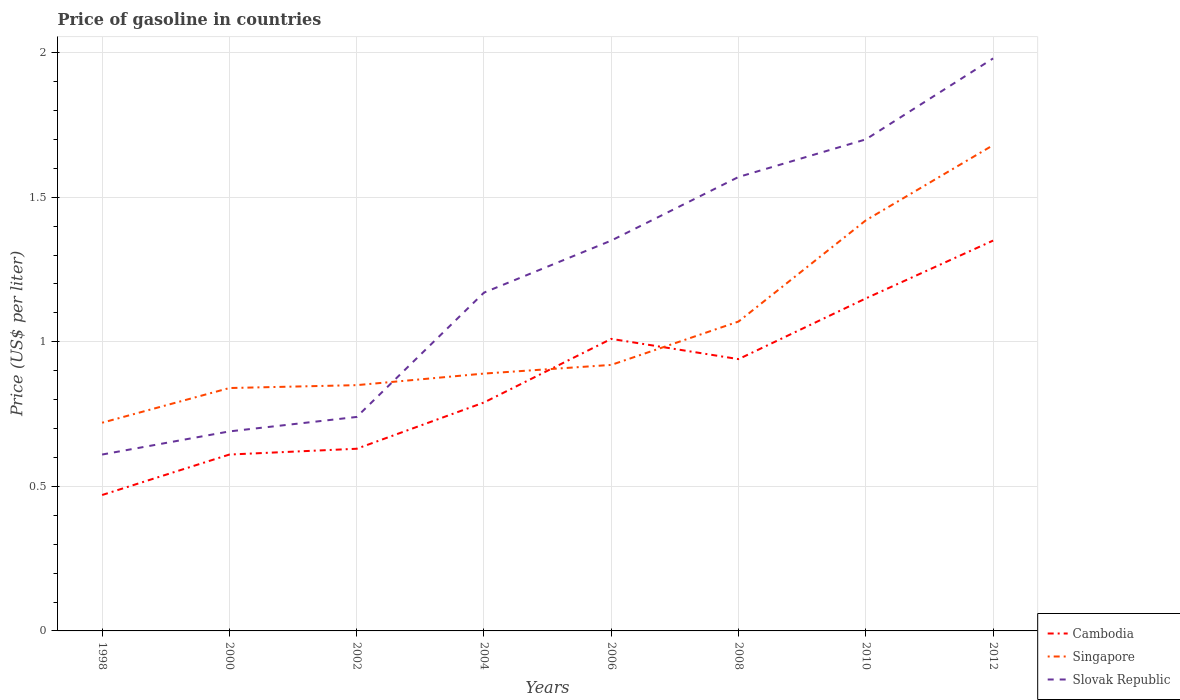How many different coloured lines are there?
Your answer should be compact. 3. Does the line corresponding to Slovak Republic intersect with the line corresponding to Cambodia?
Give a very brief answer. No. Across all years, what is the maximum price of gasoline in Cambodia?
Provide a succinct answer. 0.47. What is the total price of gasoline in Singapore in the graph?
Provide a short and direct response. -0.5. What is the difference between the highest and the second highest price of gasoline in Slovak Republic?
Make the answer very short. 1.37. What is the difference between the highest and the lowest price of gasoline in Singapore?
Offer a terse response. 3. Is the price of gasoline in Cambodia strictly greater than the price of gasoline in Singapore over the years?
Keep it short and to the point. No. How many lines are there?
Your response must be concise. 3. Are the values on the major ticks of Y-axis written in scientific E-notation?
Provide a short and direct response. No. Does the graph contain any zero values?
Give a very brief answer. No. Where does the legend appear in the graph?
Make the answer very short. Bottom right. What is the title of the graph?
Your response must be concise. Price of gasoline in countries. Does "Mongolia" appear as one of the legend labels in the graph?
Your answer should be compact. No. What is the label or title of the X-axis?
Provide a short and direct response. Years. What is the label or title of the Y-axis?
Offer a terse response. Price (US$ per liter). What is the Price (US$ per liter) in Cambodia in 1998?
Give a very brief answer. 0.47. What is the Price (US$ per liter) of Singapore in 1998?
Make the answer very short. 0.72. What is the Price (US$ per liter) of Slovak Republic in 1998?
Ensure brevity in your answer.  0.61. What is the Price (US$ per liter) of Cambodia in 2000?
Provide a short and direct response. 0.61. What is the Price (US$ per liter) in Singapore in 2000?
Give a very brief answer. 0.84. What is the Price (US$ per liter) of Slovak Republic in 2000?
Your response must be concise. 0.69. What is the Price (US$ per liter) in Cambodia in 2002?
Offer a very short reply. 0.63. What is the Price (US$ per liter) in Singapore in 2002?
Keep it short and to the point. 0.85. What is the Price (US$ per liter) of Slovak Republic in 2002?
Provide a short and direct response. 0.74. What is the Price (US$ per liter) in Cambodia in 2004?
Your response must be concise. 0.79. What is the Price (US$ per liter) in Singapore in 2004?
Provide a succinct answer. 0.89. What is the Price (US$ per liter) in Slovak Republic in 2004?
Provide a succinct answer. 1.17. What is the Price (US$ per liter) of Singapore in 2006?
Your answer should be compact. 0.92. What is the Price (US$ per liter) in Slovak Republic in 2006?
Make the answer very short. 1.35. What is the Price (US$ per liter) in Singapore in 2008?
Keep it short and to the point. 1.07. What is the Price (US$ per liter) in Slovak Republic in 2008?
Your answer should be very brief. 1.57. What is the Price (US$ per liter) of Cambodia in 2010?
Provide a short and direct response. 1.15. What is the Price (US$ per liter) of Singapore in 2010?
Offer a terse response. 1.42. What is the Price (US$ per liter) of Slovak Republic in 2010?
Make the answer very short. 1.7. What is the Price (US$ per liter) in Cambodia in 2012?
Make the answer very short. 1.35. What is the Price (US$ per liter) in Singapore in 2012?
Your answer should be compact. 1.68. What is the Price (US$ per liter) in Slovak Republic in 2012?
Your answer should be very brief. 1.98. Across all years, what is the maximum Price (US$ per liter) in Cambodia?
Provide a succinct answer. 1.35. Across all years, what is the maximum Price (US$ per liter) in Singapore?
Offer a terse response. 1.68. Across all years, what is the maximum Price (US$ per liter) of Slovak Republic?
Provide a succinct answer. 1.98. Across all years, what is the minimum Price (US$ per liter) in Cambodia?
Give a very brief answer. 0.47. Across all years, what is the minimum Price (US$ per liter) of Singapore?
Your response must be concise. 0.72. Across all years, what is the minimum Price (US$ per liter) in Slovak Republic?
Give a very brief answer. 0.61. What is the total Price (US$ per liter) in Cambodia in the graph?
Make the answer very short. 6.95. What is the total Price (US$ per liter) in Singapore in the graph?
Offer a terse response. 8.39. What is the total Price (US$ per liter) in Slovak Republic in the graph?
Offer a very short reply. 9.81. What is the difference between the Price (US$ per liter) in Cambodia in 1998 and that in 2000?
Offer a very short reply. -0.14. What is the difference between the Price (US$ per liter) of Singapore in 1998 and that in 2000?
Keep it short and to the point. -0.12. What is the difference between the Price (US$ per liter) of Slovak Republic in 1998 and that in 2000?
Offer a terse response. -0.08. What is the difference between the Price (US$ per liter) of Cambodia in 1998 and that in 2002?
Keep it short and to the point. -0.16. What is the difference between the Price (US$ per liter) in Singapore in 1998 and that in 2002?
Provide a succinct answer. -0.13. What is the difference between the Price (US$ per liter) in Slovak Republic in 1998 and that in 2002?
Your response must be concise. -0.13. What is the difference between the Price (US$ per liter) of Cambodia in 1998 and that in 2004?
Your answer should be very brief. -0.32. What is the difference between the Price (US$ per liter) in Singapore in 1998 and that in 2004?
Provide a succinct answer. -0.17. What is the difference between the Price (US$ per liter) in Slovak Republic in 1998 and that in 2004?
Offer a terse response. -0.56. What is the difference between the Price (US$ per liter) in Cambodia in 1998 and that in 2006?
Provide a short and direct response. -0.54. What is the difference between the Price (US$ per liter) of Slovak Republic in 1998 and that in 2006?
Offer a very short reply. -0.74. What is the difference between the Price (US$ per liter) of Cambodia in 1998 and that in 2008?
Give a very brief answer. -0.47. What is the difference between the Price (US$ per liter) of Singapore in 1998 and that in 2008?
Provide a succinct answer. -0.35. What is the difference between the Price (US$ per liter) of Slovak Republic in 1998 and that in 2008?
Offer a very short reply. -0.96. What is the difference between the Price (US$ per liter) of Cambodia in 1998 and that in 2010?
Offer a very short reply. -0.68. What is the difference between the Price (US$ per liter) in Slovak Republic in 1998 and that in 2010?
Give a very brief answer. -1.09. What is the difference between the Price (US$ per liter) of Cambodia in 1998 and that in 2012?
Your answer should be very brief. -0.88. What is the difference between the Price (US$ per liter) in Singapore in 1998 and that in 2012?
Your answer should be compact. -0.96. What is the difference between the Price (US$ per liter) of Slovak Republic in 1998 and that in 2012?
Keep it short and to the point. -1.37. What is the difference between the Price (US$ per liter) in Cambodia in 2000 and that in 2002?
Your answer should be compact. -0.02. What is the difference between the Price (US$ per liter) of Singapore in 2000 and that in 2002?
Ensure brevity in your answer.  -0.01. What is the difference between the Price (US$ per liter) in Cambodia in 2000 and that in 2004?
Provide a succinct answer. -0.18. What is the difference between the Price (US$ per liter) of Singapore in 2000 and that in 2004?
Ensure brevity in your answer.  -0.05. What is the difference between the Price (US$ per liter) of Slovak Republic in 2000 and that in 2004?
Offer a very short reply. -0.48. What is the difference between the Price (US$ per liter) in Cambodia in 2000 and that in 2006?
Offer a very short reply. -0.4. What is the difference between the Price (US$ per liter) in Singapore in 2000 and that in 2006?
Keep it short and to the point. -0.08. What is the difference between the Price (US$ per liter) of Slovak Republic in 2000 and that in 2006?
Offer a very short reply. -0.66. What is the difference between the Price (US$ per liter) in Cambodia in 2000 and that in 2008?
Ensure brevity in your answer.  -0.33. What is the difference between the Price (US$ per liter) of Singapore in 2000 and that in 2008?
Your answer should be very brief. -0.23. What is the difference between the Price (US$ per liter) in Slovak Republic in 2000 and that in 2008?
Offer a very short reply. -0.88. What is the difference between the Price (US$ per liter) of Cambodia in 2000 and that in 2010?
Give a very brief answer. -0.54. What is the difference between the Price (US$ per liter) of Singapore in 2000 and that in 2010?
Provide a succinct answer. -0.58. What is the difference between the Price (US$ per liter) in Slovak Republic in 2000 and that in 2010?
Your response must be concise. -1.01. What is the difference between the Price (US$ per liter) in Cambodia in 2000 and that in 2012?
Make the answer very short. -0.74. What is the difference between the Price (US$ per liter) in Singapore in 2000 and that in 2012?
Make the answer very short. -0.84. What is the difference between the Price (US$ per liter) of Slovak Republic in 2000 and that in 2012?
Offer a very short reply. -1.29. What is the difference between the Price (US$ per liter) of Cambodia in 2002 and that in 2004?
Offer a very short reply. -0.16. What is the difference between the Price (US$ per liter) of Singapore in 2002 and that in 2004?
Keep it short and to the point. -0.04. What is the difference between the Price (US$ per liter) of Slovak Republic in 2002 and that in 2004?
Give a very brief answer. -0.43. What is the difference between the Price (US$ per liter) of Cambodia in 2002 and that in 2006?
Provide a succinct answer. -0.38. What is the difference between the Price (US$ per liter) of Singapore in 2002 and that in 2006?
Ensure brevity in your answer.  -0.07. What is the difference between the Price (US$ per liter) of Slovak Republic in 2002 and that in 2006?
Your response must be concise. -0.61. What is the difference between the Price (US$ per liter) in Cambodia in 2002 and that in 2008?
Make the answer very short. -0.31. What is the difference between the Price (US$ per liter) in Singapore in 2002 and that in 2008?
Make the answer very short. -0.22. What is the difference between the Price (US$ per liter) in Slovak Republic in 2002 and that in 2008?
Offer a very short reply. -0.83. What is the difference between the Price (US$ per liter) of Cambodia in 2002 and that in 2010?
Give a very brief answer. -0.52. What is the difference between the Price (US$ per liter) in Singapore in 2002 and that in 2010?
Keep it short and to the point. -0.57. What is the difference between the Price (US$ per liter) of Slovak Republic in 2002 and that in 2010?
Ensure brevity in your answer.  -0.96. What is the difference between the Price (US$ per liter) of Cambodia in 2002 and that in 2012?
Your answer should be compact. -0.72. What is the difference between the Price (US$ per liter) of Singapore in 2002 and that in 2012?
Your answer should be compact. -0.83. What is the difference between the Price (US$ per liter) in Slovak Republic in 2002 and that in 2012?
Make the answer very short. -1.24. What is the difference between the Price (US$ per liter) in Cambodia in 2004 and that in 2006?
Give a very brief answer. -0.22. What is the difference between the Price (US$ per liter) in Singapore in 2004 and that in 2006?
Your answer should be compact. -0.03. What is the difference between the Price (US$ per liter) of Slovak Republic in 2004 and that in 2006?
Your answer should be very brief. -0.18. What is the difference between the Price (US$ per liter) of Singapore in 2004 and that in 2008?
Keep it short and to the point. -0.18. What is the difference between the Price (US$ per liter) in Cambodia in 2004 and that in 2010?
Keep it short and to the point. -0.36. What is the difference between the Price (US$ per liter) of Singapore in 2004 and that in 2010?
Give a very brief answer. -0.53. What is the difference between the Price (US$ per liter) of Slovak Republic in 2004 and that in 2010?
Provide a succinct answer. -0.53. What is the difference between the Price (US$ per liter) of Cambodia in 2004 and that in 2012?
Your answer should be compact. -0.56. What is the difference between the Price (US$ per liter) of Singapore in 2004 and that in 2012?
Provide a short and direct response. -0.79. What is the difference between the Price (US$ per liter) of Slovak Republic in 2004 and that in 2012?
Your answer should be very brief. -0.81. What is the difference between the Price (US$ per liter) in Cambodia in 2006 and that in 2008?
Provide a short and direct response. 0.07. What is the difference between the Price (US$ per liter) in Slovak Republic in 2006 and that in 2008?
Give a very brief answer. -0.22. What is the difference between the Price (US$ per liter) of Cambodia in 2006 and that in 2010?
Offer a terse response. -0.14. What is the difference between the Price (US$ per liter) in Singapore in 2006 and that in 2010?
Keep it short and to the point. -0.5. What is the difference between the Price (US$ per liter) of Slovak Republic in 2006 and that in 2010?
Offer a very short reply. -0.35. What is the difference between the Price (US$ per liter) of Cambodia in 2006 and that in 2012?
Offer a terse response. -0.34. What is the difference between the Price (US$ per liter) of Singapore in 2006 and that in 2012?
Offer a very short reply. -0.76. What is the difference between the Price (US$ per liter) in Slovak Republic in 2006 and that in 2012?
Your answer should be compact. -0.63. What is the difference between the Price (US$ per liter) in Cambodia in 2008 and that in 2010?
Make the answer very short. -0.21. What is the difference between the Price (US$ per liter) in Singapore in 2008 and that in 2010?
Your answer should be compact. -0.35. What is the difference between the Price (US$ per liter) of Slovak Republic in 2008 and that in 2010?
Give a very brief answer. -0.13. What is the difference between the Price (US$ per liter) in Cambodia in 2008 and that in 2012?
Your answer should be very brief. -0.41. What is the difference between the Price (US$ per liter) of Singapore in 2008 and that in 2012?
Your answer should be very brief. -0.61. What is the difference between the Price (US$ per liter) in Slovak Republic in 2008 and that in 2012?
Your answer should be compact. -0.41. What is the difference between the Price (US$ per liter) of Singapore in 2010 and that in 2012?
Offer a very short reply. -0.26. What is the difference between the Price (US$ per liter) of Slovak Republic in 2010 and that in 2012?
Your answer should be very brief. -0.28. What is the difference between the Price (US$ per liter) in Cambodia in 1998 and the Price (US$ per liter) in Singapore in 2000?
Keep it short and to the point. -0.37. What is the difference between the Price (US$ per liter) of Cambodia in 1998 and the Price (US$ per liter) of Slovak Republic in 2000?
Your response must be concise. -0.22. What is the difference between the Price (US$ per liter) in Cambodia in 1998 and the Price (US$ per liter) in Singapore in 2002?
Offer a very short reply. -0.38. What is the difference between the Price (US$ per liter) of Cambodia in 1998 and the Price (US$ per liter) of Slovak Republic in 2002?
Provide a short and direct response. -0.27. What is the difference between the Price (US$ per liter) in Singapore in 1998 and the Price (US$ per liter) in Slovak Republic in 2002?
Offer a terse response. -0.02. What is the difference between the Price (US$ per liter) of Cambodia in 1998 and the Price (US$ per liter) of Singapore in 2004?
Your response must be concise. -0.42. What is the difference between the Price (US$ per liter) of Cambodia in 1998 and the Price (US$ per liter) of Slovak Republic in 2004?
Your answer should be compact. -0.7. What is the difference between the Price (US$ per liter) of Singapore in 1998 and the Price (US$ per liter) of Slovak Republic in 2004?
Your response must be concise. -0.45. What is the difference between the Price (US$ per liter) in Cambodia in 1998 and the Price (US$ per liter) in Singapore in 2006?
Your response must be concise. -0.45. What is the difference between the Price (US$ per liter) of Cambodia in 1998 and the Price (US$ per liter) of Slovak Republic in 2006?
Keep it short and to the point. -0.88. What is the difference between the Price (US$ per liter) in Singapore in 1998 and the Price (US$ per liter) in Slovak Republic in 2006?
Give a very brief answer. -0.63. What is the difference between the Price (US$ per liter) of Cambodia in 1998 and the Price (US$ per liter) of Singapore in 2008?
Provide a succinct answer. -0.6. What is the difference between the Price (US$ per liter) in Singapore in 1998 and the Price (US$ per liter) in Slovak Republic in 2008?
Offer a very short reply. -0.85. What is the difference between the Price (US$ per liter) of Cambodia in 1998 and the Price (US$ per liter) of Singapore in 2010?
Ensure brevity in your answer.  -0.95. What is the difference between the Price (US$ per liter) of Cambodia in 1998 and the Price (US$ per liter) of Slovak Republic in 2010?
Offer a terse response. -1.23. What is the difference between the Price (US$ per liter) of Singapore in 1998 and the Price (US$ per liter) of Slovak Republic in 2010?
Make the answer very short. -0.98. What is the difference between the Price (US$ per liter) of Cambodia in 1998 and the Price (US$ per liter) of Singapore in 2012?
Ensure brevity in your answer.  -1.21. What is the difference between the Price (US$ per liter) of Cambodia in 1998 and the Price (US$ per liter) of Slovak Republic in 2012?
Provide a succinct answer. -1.51. What is the difference between the Price (US$ per liter) of Singapore in 1998 and the Price (US$ per liter) of Slovak Republic in 2012?
Give a very brief answer. -1.26. What is the difference between the Price (US$ per liter) of Cambodia in 2000 and the Price (US$ per liter) of Singapore in 2002?
Ensure brevity in your answer.  -0.24. What is the difference between the Price (US$ per liter) of Cambodia in 2000 and the Price (US$ per liter) of Slovak Republic in 2002?
Your response must be concise. -0.13. What is the difference between the Price (US$ per liter) of Singapore in 2000 and the Price (US$ per liter) of Slovak Republic in 2002?
Make the answer very short. 0.1. What is the difference between the Price (US$ per liter) in Cambodia in 2000 and the Price (US$ per liter) in Singapore in 2004?
Your response must be concise. -0.28. What is the difference between the Price (US$ per liter) in Cambodia in 2000 and the Price (US$ per liter) in Slovak Republic in 2004?
Your response must be concise. -0.56. What is the difference between the Price (US$ per liter) in Singapore in 2000 and the Price (US$ per liter) in Slovak Republic in 2004?
Ensure brevity in your answer.  -0.33. What is the difference between the Price (US$ per liter) of Cambodia in 2000 and the Price (US$ per liter) of Singapore in 2006?
Offer a very short reply. -0.31. What is the difference between the Price (US$ per liter) of Cambodia in 2000 and the Price (US$ per liter) of Slovak Republic in 2006?
Provide a succinct answer. -0.74. What is the difference between the Price (US$ per liter) of Singapore in 2000 and the Price (US$ per liter) of Slovak Republic in 2006?
Keep it short and to the point. -0.51. What is the difference between the Price (US$ per liter) of Cambodia in 2000 and the Price (US$ per liter) of Singapore in 2008?
Your answer should be compact. -0.46. What is the difference between the Price (US$ per liter) of Cambodia in 2000 and the Price (US$ per liter) of Slovak Republic in 2008?
Provide a succinct answer. -0.96. What is the difference between the Price (US$ per liter) in Singapore in 2000 and the Price (US$ per liter) in Slovak Republic in 2008?
Your response must be concise. -0.73. What is the difference between the Price (US$ per liter) in Cambodia in 2000 and the Price (US$ per liter) in Singapore in 2010?
Offer a terse response. -0.81. What is the difference between the Price (US$ per liter) of Cambodia in 2000 and the Price (US$ per liter) of Slovak Republic in 2010?
Your answer should be very brief. -1.09. What is the difference between the Price (US$ per liter) in Singapore in 2000 and the Price (US$ per liter) in Slovak Republic in 2010?
Your response must be concise. -0.86. What is the difference between the Price (US$ per liter) in Cambodia in 2000 and the Price (US$ per liter) in Singapore in 2012?
Ensure brevity in your answer.  -1.07. What is the difference between the Price (US$ per liter) in Cambodia in 2000 and the Price (US$ per liter) in Slovak Republic in 2012?
Offer a terse response. -1.37. What is the difference between the Price (US$ per liter) in Singapore in 2000 and the Price (US$ per liter) in Slovak Republic in 2012?
Provide a succinct answer. -1.14. What is the difference between the Price (US$ per liter) in Cambodia in 2002 and the Price (US$ per liter) in Singapore in 2004?
Give a very brief answer. -0.26. What is the difference between the Price (US$ per liter) of Cambodia in 2002 and the Price (US$ per liter) of Slovak Republic in 2004?
Give a very brief answer. -0.54. What is the difference between the Price (US$ per liter) of Singapore in 2002 and the Price (US$ per liter) of Slovak Republic in 2004?
Provide a short and direct response. -0.32. What is the difference between the Price (US$ per liter) in Cambodia in 2002 and the Price (US$ per liter) in Singapore in 2006?
Provide a short and direct response. -0.29. What is the difference between the Price (US$ per liter) of Cambodia in 2002 and the Price (US$ per liter) of Slovak Republic in 2006?
Keep it short and to the point. -0.72. What is the difference between the Price (US$ per liter) of Cambodia in 2002 and the Price (US$ per liter) of Singapore in 2008?
Ensure brevity in your answer.  -0.44. What is the difference between the Price (US$ per liter) of Cambodia in 2002 and the Price (US$ per liter) of Slovak Republic in 2008?
Your answer should be compact. -0.94. What is the difference between the Price (US$ per liter) in Singapore in 2002 and the Price (US$ per liter) in Slovak Republic in 2008?
Your response must be concise. -0.72. What is the difference between the Price (US$ per liter) in Cambodia in 2002 and the Price (US$ per liter) in Singapore in 2010?
Your answer should be compact. -0.79. What is the difference between the Price (US$ per liter) of Cambodia in 2002 and the Price (US$ per liter) of Slovak Republic in 2010?
Offer a very short reply. -1.07. What is the difference between the Price (US$ per liter) of Singapore in 2002 and the Price (US$ per liter) of Slovak Republic in 2010?
Keep it short and to the point. -0.85. What is the difference between the Price (US$ per liter) of Cambodia in 2002 and the Price (US$ per liter) of Singapore in 2012?
Provide a succinct answer. -1.05. What is the difference between the Price (US$ per liter) of Cambodia in 2002 and the Price (US$ per liter) of Slovak Republic in 2012?
Ensure brevity in your answer.  -1.35. What is the difference between the Price (US$ per liter) in Singapore in 2002 and the Price (US$ per liter) in Slovak Republic in 2012?
Offer a very short reply. -1.13. What is the difference between the Price (US$ per liter) of Cambodia in 2004 and the Price (US$ per liter) of Singapore in 2006?
Offer a very short reply. -0.13. What is the difference between the Price (US$ per liter) in Cambodia in 2004 and the Price (US$ per liter) in Slovak Republic in 2006?
Provide a short and direct response. -0.56. What is the difference between the Price (US$ per liter) in Singapore in 2004 and the Price (US$ per liter) in Slovak Republic in 2006?
Make the answer very short. -0.46. What is the difference between the Price (US$ per liter) in Cambodia in 2004 and the Price (US$ per liter) in Singapore in 2008?
Give a very brief answer. -0.28. What is the difference between the Price (US$ per liter) of Cambodia in 2004 and the Price (US$ per liter) of Slovak Republic in 2008?
Give a very brief answer. -0.78. What is the difference between the Price (US$ per liter) in Singapore in 2004 and the Price (US$ per liter) in Slovak Republic in 2008?
Your response must be concise. -0.68. What is the difference between the Price (US$ per liter) of Cambodia in 2004 and the Price (US$ per liter) of Singapore in 2010?
Your answer should be compact. -0.63. What is the difference between the Price (US$ per liter) of Cambodia in 2004 and the Price (US$ per liter) of Slovak Republic in 2010?
Your answer should be very brief. -0.91. What is the difference between the Price (US$ per liter) in Singapore in 2004 and the Price (US$ per liter) in Slovak Republic in 2010?
Offer a terse response. -0.81. What is the difference between the Price (US$ per liter) in Cambodia in 2004 and the Price (US$ per liter) in Singapore in 2012?
Keep it short and to the point. -0.89. What is the difference between the Price (US$ per liter) of Cambodia in 2004 and the Price (US$ per liter) of Slovak Republic in 2012?
Provide a succinct answer. -1.19. What is the difference between the Price (US$ per liter) of Singapore in 2004 and the Price (US$ per liter) of Slovak Republic in 2012?
Your response must be concise. -1.09. What is the difference between the Price (US$ per liter) in Cambodia in 2006 and the Price (US$ per liter) in Singapore in 2008?
Offer a terse response. -0.06. What is the difference between the Price (US$ per liter) in Cambodia in 2006 and the Price (US$ per liter) in Slovak Republic in 2008?
Keep it short and to the point. -0.56. What is the difference between the Price (US$ per liter) in Singapore in 2006 and the Price (US$ per liter) in Slovak Republic in 2008?
Offer a very short reply. -0.65. What is the difference between the Price (US$ per liter) of Cambodia in 2006 and the Price (US$ per liter) of Singapore in 2010?
Your answer should be very brief. -0.41. What is the difference between the Price (US$ per liter) in Cambodia in 2006 and the Price (US$ per liter) in Slovak Republic in 2010?
Your answer should be very brief. -0.69. What is the difference between the Price (US$ per liter) in Singapore in 2006 and the Price (US$ per liter) in Slovak Republic in 2010?
Offer a very short reply. -0.78. What is the difference between the Price (US$ per liter) of Cambodia in 2006 and the Price (US$ per liter) of Singapore in 2012?
Offer a terse response. -0.67. What is the difference between the Price (US$ per liter) in Cambodia in 2006 and the Price (US$ per liter) in Slovak Republic in 2012?
Provide a succinct answer. -0.97. What is the difference between the Price (US$ per liter) of Singapore in 2006 and the Price (US$ per liter) of Slovak Republic in 2012?
Your response must be concise. -1.06. What is the difference between the Price (US$ per liter) in Cambodia in 2008 and the Price (US$ per liter) in Singapore in 2010?
Offer a very short reply. -0.48. What is the difference between the Price (US$ per liter) in Cambodia in 2008 and the Price (US$ per liter) in Slovak Republic in 2010?
Keep it short and to the point. -0.76. What is the difference between the Price (US$ per liter) of Singapore in 2008 and the Price (US$ per liter) of Slovak Republic in 2010?
Offer a very short reply. -0.63. What is the difference between the Price (US$ per liter) of Cambodia in 2008 and the Price (US$ per liter) of Singapore in 2012?
Provide a succinct answer. -0.74. What is the difference between the Price (US$ per liter) of Cambodia in 2008 and the Price (US$ per liter) of Slovak Republic in 2012?
Your answer should be compact. -1.04. What is the difference between the Price (US$ per liter) in Singapore in 2008 and the Price (US$ per liter) in Slovak Republic in 2012?
Provide a succinct answer. -0.91. What is the difference between the Price (US$ per liter) in Cambodia in 2010 and the Price (US$ per liter) in Singapore in 2012?
Offer a terse response. -0.53. What is the difference between the Price (US$ per liter) in Cambodia in 2010 and the Price (US$ per liter) in Slovak Republic in 2012?
Offer a very short reply. -0.83. What is the difference between the Price (US$ per liter) of Singapore in 2010 and the Price (US$ per liter) of Slovak Republic in 2012?
Keep it short and to the point. -0.56. What is the average Price (US$ per liter) in Cambodia per year?
Provide a short and direct response. 0.87. What is the average Price (US$ per liter) of Singapore per year?
Provide a short and direct response. 1.05. What is the average Price (US$ per liter) in Slovak Republic per year?
Give a very brief answer. 1.23. In the year 1998, what is the difference between the Price (US$ per liter) of Cambodia and Price (US$ per liter) of Slovak Republic?
Make the answer very short. -0.14. In the year 1998, what is the difference between the Price (US$ per liter) in Singapore and Price (US$ per liter) in Slovak Republic?
Your response must be concise. 0.11. In the year 2000, what is the difference between the Price (US$ per liter) of Cambodia and Price (US$ per liter) of Singapore?
Your response must be concise. -0.23. In the year 2000, what is the difference between the Price (US$ per liter) of Cambodia and Price (US$ per liter) of Slovak Republic?
Your response must be concise. -0.08. In the year 2002, what is the difference between the Price (US$ per liter) in Cambodia and Price (US$ per liter) in Singapore?
Offer a very short reply. -0.22. In the year 2002, what is the difference between the Price (US$ per liter) of Cambodia and Price (US$ per liter) of Slovak Republic?
Offer a very short reply. -0.11. In the year 2002, what is the difference between the Price (US$ per liter) of Singapore and Price (US$ per liter) of Slovak Republic?
Your answer should be compact. 0.11. In the year 2004, what is the difference between the Price (US$ per liter) of Cambodia and Price (US$ per liter) of Singapore?
Offer a very short reply. -0.1. In the year 2004, what is the difference between the Price (US$ per liter) of Cambodia and Price (US$ per liter) of Slovak Republic?
Provide a short and direct response. -0.38. In the year 2004, what is the difference between the Price (US$ per liter) of Singapore and Price (US$ per liter) of Slovak Republic?
Make the answer very short. -0.28. In the year 2006, what is the difference between the Price (US$ per liter) in Cambodia and Price (US$ per liter) in Singapore?
Give a very brief answer. 0.09. In the year 2006, what is the difference between the Price (US$ per liter) of Cambodia and Price (US$ per liter) of Slovak Republic?
Offer a very short reply. -0.34. In the year 2006, what is the difference between the Price (US$ per liter) of Singapore and Price (US$ per liter) of Slovak Republic?
Your answer should be very brief. -0.43. In the year 2008, what is the difference between the Price (US$ per liter) of Cambodia and Price (US$ per liter) of Singapore?
Provide a short and direct response. -0.13. In the year 2008, what is the difference between the Price (US$ per liter) of Cambodia and Price (US$ per liter) of Slovak Republic?
Offer a very short reply. -0.63. In the year 2010, what is the difference between the Price (US$ per liter) of Cambodia and Price (US$ per liter) of Singapore?
Keep it short and to the point. -0.27. In the year 2010, what is the difference between the Price (US$ per liter) in Cambodia and Price (US$ per liter) in Slovak Republic?
Your response must be concise. -0.55. In the year 2010, what is the difference between the Price (US$ per liter) in Singapore and Price (US$ per liter) in Slovak Republic?
Offer a terse response. -0.28. In the year 2012, what is the difference between the Price (US$ per liter) in Cambodia and Price (US$ per liter) in Singapore?
Give a very brief answer. -0.33. In the year 2012, what is the difference between the Price (US$ per liter) in Cambodia and Price (US$ per liter) in Slovak Republic?
Give a very brief answer. -0.63. What is the ratio of the Price (US$ per liter) of Cambodia in 1998 to that in 2000?
Offer a very short reply. 0.77. What is the ratio of the Price (US$ per liter) of Slovak Republic in 1998 to that in 2000?
Provide a succinct answer. 0.88. What is the ratio of the Price (US$ per liter) in Cambodia in 1998 to that in 2002?
Your answer should be compact. 0.75. What is the ratio of the Price (US$ per liter) of Singapore in 1998 to that in 2002?
Give a very brief answer. 0.85. What is the ratio of the Price (US$ per liter) in Slovak Republic in 1998 to that in 2002?
Provide a succinct answer. 0.82. What is the ratio of the Price (US$ per liter) in Cambodia in 1998 to that in 2004?
Offer a very short reply. 0.59. What is the ratio of the Price (US$ per liter) of Singapore in 1998 to that in 2004?
Keep it short and to the point. 0.81. What is the ratio of the Price (US$ per liter) in Slovak Republic in 1998 to that in 2004?
Provide a succinct answer. 0.52. What is the ratio of the Price (US$ per liter) of Cambodia in 1998 to that in 2006?
Offer a terse response. 0.47. What is the ratio of the Price (US$ per liter) in Singapore in 1998 to that in 2006?
Your answer should be compact. 0.78. What is the ratio of the Price (US$ per liter) of Slovak Republic in 1998 to that in 2006?
Make the answer very short. 0.45. What is the ratio of the Price (US$ per liter) of Cambodia in 1998 to that in 2008?
Provide a short and direct response. 0.5. What is the ratio of the Price (US$ per liter) of Singapore in 1998 to that in 2008?
Provide a succinct answer. 0.67. What is the ratio of the Price (US$ per liter) in Slovak Republic in 1998 to that in 2008?
Keep it short and to the point. 0.39. What is the ratio of the Price (US$ per liter) of Cambodia in 1998 to that in 2010?
Provide a short and direct response. 0.41. What is the ratio of the Price (US$ per liter) in Singapore in 1998 to that in 2010?
Provide a short and direct response. 0.51. What is the ratio of the Price (US$ per liter) in Slovak Republic in 1998 to that in 2010?
Provide a short and direct response. 0.36. What is the ratio of the Price (US$ per liter) in Cambodia in 1998 to that in 2012?
Your answer should be compact. 0.35. What is the ratio of the Price (US$ per liter) of Singapore in 1998 to that in 2012?
Provide a short and direct response. 0.43. What is the ratio of the Price (US$ per liter) of Slovak Republic in 1998 to that in 2012?
Provide a succinct answer. 0.31. What is the ratio of the Price (US$ per liter) of Cambodia in 2000 to that in 2002?
Your answer should be very brief. 0.97. What is the ratio of the Price (US$ per liter) of Slovak Republic in 2000 to that in 2002?
Your answer should be compact. 0.93. What is the ratio of the Price (US$ per liter) of Cambodia in 2000 to that in 2004?
Offer a terse response. 0.77. What is the ratio of the Price (US$ per liter) of Singapore in 2000 to that in 2004?
Your answer should be compact. 0.94. What is the ratio of the Price (US$ per liter) of Slovak Republic in 2000 to that in 2004?
Give a very brief answer. 0.59. What is the ratio of the Price (US$ per liter) of Cambodia in 2000 to that in 2006?
Your answer should be compact. 0.6. What is the ratio of the Price (US$ per liter) of Slovak Republic in 2000 to that in 2006?
Keep it short and to the point. 0.51. What is the ratio of the Price (US$ per liter) of Cambodia in 2000 to that in 2008?
Ensure brevity in your answer.  0.65. What is the ratio of the Price (US$ per liter) of Singapore in 2000 to that in 2008?
Your answer should be very brief. 0.79. What is the ratio of the Price (US$ per liter) of Slovak Republic in 2000 to that in 2008?
Give a very brief answer. 0.44. What is the ratio of the Price (US$ per liter) of Cambodia in 2000 to that in 2010?
Give a very brief answer. 0.53. What is the ratio of the Price (US$ per liter) in Singapore in 2000 to that in 2010?
Keep it short and to the point. 0.59. What is the ratio of the Price (US$ per liter) in Slovak Republic in 2000 to that in 2010?
Your answer should be very brief. 0.41. What is the ratio of the Price (US$ per liter) in Cambodia in 2000 to that in 2012?
Keep it short and to the point. 0.45. What is the ratio of the Price (US$ per liter) of Slovak Republic in 2000 to that in 2012?
Offer a terse response. 0.35. What is the ratio of the Price (US$ per liter) in Cambodia in 2002 to that in 2004?
Offer a terse response. 0.8. What is the ratio of the Price (US$ per liter) of Singapore in 2002 to that in 2004?
Give a very brief answer. 0.96. What is the ratio of the Price (US$ per liter) of Slovak Republic in 2002 to that in 2004?
Offer a very short reply. 0.63. What is the ratio of the Price (US$ per liter) in Cambodia in 2002 to that in 2006?
Provide a short and direct response. 0.62. What is the ratio of the Price (US$ per liter) of Singapore in 2002 to that in 2006?
Your answer should be compact. 0.92. What is the ratio of the Price (US$ per liter) in Slovak Republic in 2002 to that in 2006?
Offer a terse response. 0.55. What is the ratio of the Price (US$ per liter) in Cambodia in 2002 to that in 2008?
Provide a succinct answer. 0.67. What is the ratio of the Price (US$ per liter) of Singapore in 2002 to that in 2008?
Your response must be concise. 0.79. What is the ratio of the Price (US$ per liter) of Slovak Republic in 2002 to that in 2008?
Ensure brevity in your answer.  0.47. What is the ratio of the Price (US$ per liter) of Cambodia in 2002 to that in 2010?
Your response must be concise. 0.55. What is the ratio of the Price (US$ per liter) of Singapore in 2002 to that in 2010?
Keep it short and to the point. 0.6. What is the ratio of the Price (US$ per liter) of Slovak Republic in 2002 to that in 2010?
Keep it short and to the point. 0.44. What is the ratio of the Price (US$ per liter) of Cambodia in 2002 to that in 2012?
Provide a succinct answer. 0.47. What is the ratio of the Price (US$ per liter) of Singapore in 2002 to that in 2012?
Give a very brief answer. 0.51. What is the ratio of the Price (US$ per liter) in Slovak Republic in 2002 to that in 2012?
Provide a succinct answer. 0.37. What is the ratio of the Price (US$ per liter) in Cambodia in 2004 to that in 2006?
Make the answer very short. 0.78. What is the ratio of the Price (US$ per liter) of Singapore in 2004 to that in 2006?
Ensure brevity in your answer.  0.97. What is the ratio of the Price (US$ per liter) of Slovak Republic in 2004 to that in 2006?
Make the answer very short. 0.87. What is the ratio of the Price (US$ per liter) of Cambodia in 2004 to that in 2008?
Offer a very short reply. 0.84. What is the ratio of the Price (US$ per liter) in Singapore in 2004 to that in 2008?
Keep it short and to the point. 0.83. What is the ratio of the Price (US$ per liter) in Slovak Republic in 2004 to that in 2008?
Make the answer very short. 0.75. What is the ratio of the Price (US$ per liter) in Cambodia in 2004 to that in 2010?
Give a very brief answer. 0.69. What is the ratio of the Price (US$ per liter) in Singapore in 2004 to that in 2010?
Keep it short and to the point. 0.63. What is the ratio of the Price (US$ per liter) in Slovak Republic in 2004 to that in 2010?
Your answer should be compact. 0.69. What is the ratio of the Price (US$ per liter) of Cambodia in 2004 to that in 2012?
Keep it short and to the point. 0.59. What is the ratio of the Price (US$ per liter) of Singapore in 2004 to that in 2012?
Give a very brief answer. 0.53. What is the ratio of the Price (US$ per liter) of Slovak Republic in 2004 to that in 2012?
Provide a succinct answer. 0.59. What is the ratio of the Price (US$ per liter) in Cambodia in 2006 to that in 2008?
Your answer should be compact. 1.07. What is the ratio of the Price (US$ per liter) in Singapore in 2006 to that in 2008?
Your response must be concise. 0.86. What is the ratio of the Price (US$ per liter) in Slovak Republic in 2006 to that in 2008?
Ensure brevity in your answer.  0.86. What is the ratio of the Price (US$ per liter) of Cambodia in 2006 to that in 2010?
Offer a terse response. 0.88. What is the ratio of the Price (US$ per liter) in Singapore in 2006 to that in 2010?
Give a very brief answer. 0.65. What is the ratio of the Price (US$ per liter) in Slovak Republic in 2006 to that in 2010?
Give a very brief answer. 0.79. What is the ratio of the Price (US$ per liter) of Cambodia in 2006 to that in 2012?
Offer a terse response. 0.75. What is the ratio of the Price (US$ per liter) in Singapore in 2006 to that in 2012?
Offer a terse response. 0.55. What is the ratio of the Price (US$ per liter) of Slovak Republic in 2006 to that in 2012?
Offer a very short reply. 0.68. What is the ratio of the Price (US$ per liter) in Cambodia in 2008 to that in 2010?
Ensure brevity in your answer.  0.82. What is the ratio of the Price (US$ per liter) in Singapore in 2008 to that in 2010?
Offer a terse response. 0.75. What is the ratio of the Price (US$ per liter) of Slovak Republic in 2008 to that in 2010?
Provide a short and direct response. 0.92. What is the ratio of the Price (US$ per liter) of Cambodia in 2008 to that in 2012?
Give a very brief answer. 0.7. What is the ratio of the Price (US$ per liter) of Singapore in 2008 to that in 2012?
Offer a very short reply. 0.64. What is the ratio of the Price (US$ per liter) in Slovak Republic in 2008 to that in 2012?
Your answer should be very brief. 0.79. What is the ratio of the Price (US$ per liter) of Cambodia in 2010 to that in 2012?
Make the answer very short. 0.85. What is the ratio of the Price (US$ per liter) in Singapore in 2010 to that in 2012?
Your response must be concise. 0.85. What is the ratio of the Price (US$ per liter) in Slovak Republic in 2010 to that in 2012?
Give a very brief answer. 0.86. What is the difference between the highest and the second highest Price (US$ per liter) of Singapore?
Your answer should be very brief. 0.26. What is the difference between the highest and the second highest Price (US$ per liter) of Slovak Republic?
Offer a very short reply. 0.28. What is the difference between the highest and the lowest Price (US$ per liter) of Cambodia?
Provide a succinct answer. 0.88. What is the difference between the highest and the lowest Price (US$ per liter) in Singapore?
Provide a succinct answer. 0.96. What is the difference between the highest and the lowest Price (US$ per liter) of Slovak Republic?
Offer a terse response. 1.37. 